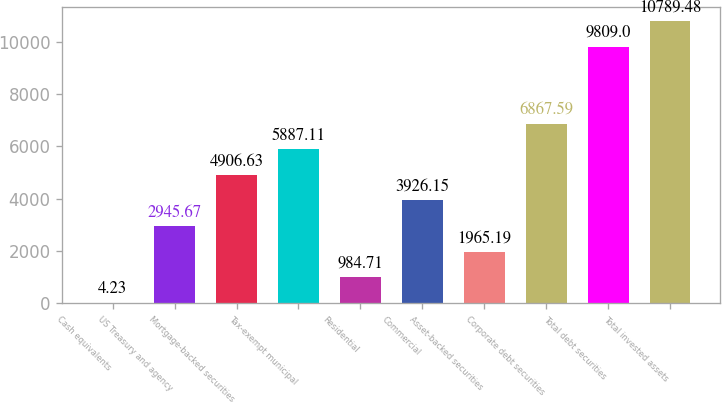Convert chart. <chart><loc_0><loc_0><loc_500><loc_500><bar_chart><fcel>Cash equivalents<fcel>US Treasury and agency<fcel>Mortgage-backed securities<fcel>Tax-exempt municipal<fcel>Residential<fcel>Commercial<fcel>Asset-backed securities<fcel>Corporate debt securities<fcel>Total debt securities<fcel>Total invested assets<nl><fcel>4.23<fcel>2945.67<fcel>4906.63<fcel>5887.11<fcel>984.71<fcel>3926.15<fcel>1965.19<fcel>6867.59<fcel>9809<fcel>10789.5<nl></chart> 